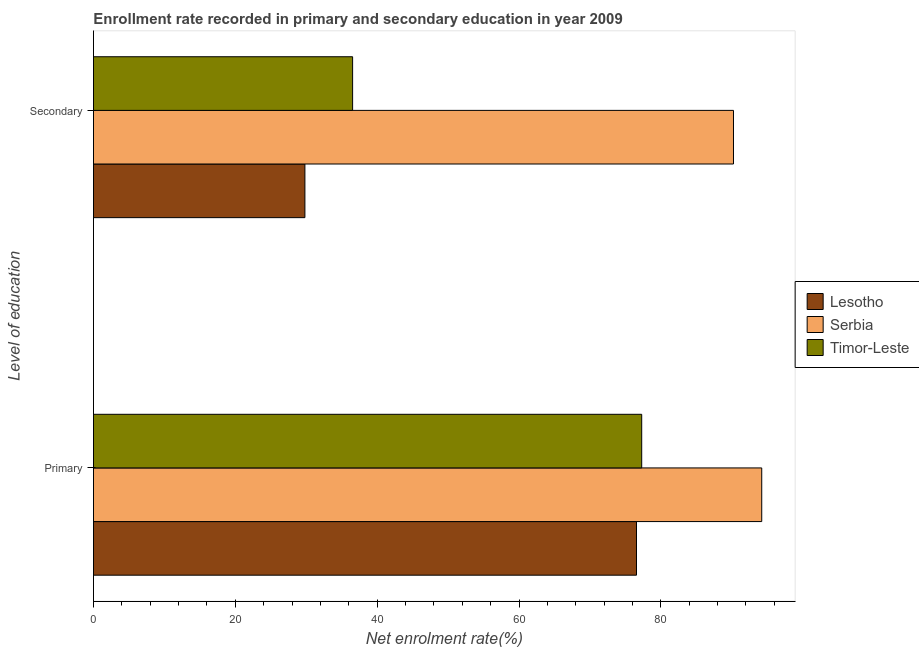How many different coloured bars are there?
Your response must be concise. 3. Are the number of bars per tick equal to the number of legend labels?
Ensure brevity in your answer.  Yes. Are the number of bars on each tick of the Y-axis equal?
Offer a very short reply. Yes. How many bars are there on the 2nd tick from the top?
Give a very brief answer. 3. How many bars are there on the 1st tick from the bottom?
Make the answer very short. 3. What is the label of the 1st group of bars from the top?
Keep it short and to the point. Secondary. What is the enrollment rate in primary education in Timor-Leste?
Your answer should be compact. 77.3. Across all countries, what is the maximum enrollment rate in secondary education?
Your response must be concise. 90.24. Across all countries, what is the minimum enrollment rate in secondary education?
Keep it short and to the point. 29.81. In which country was the enrollment rate in secondary education maximum?
Your answer should be compact. Serbia. In which country was the enrollment rate in primary education minimum?
Provide a short and direct response. Lesotho. What is the total enrollment rate in primary education in the graph?
Ensure brevity in your answer.  248.09. What is the difference between the enrollment rate in primary education in Lesotho and that in Serbia?
Offer a terse response. -17.66. What is the difference between the enrollment rate in primary education in Serbia and the enrollment rate in secondary education in Lesotho?
Keep it short and to the point. 64.41. What is the average enrollment rate in primary education per country?
Provide a short and direct response. 82.7. What is the difference between the enrollment rate in primary education and enrollment rate in secondary education in Lesotho?
Your response must be concise. 46.75. What is the ratio of the enrollment rate in secondary education in Serbia to that in Timor-Leste?
Provide a short and direct response. 2.47. In how many countries, is the enrollment rate in secondary education greater than the average enrollment rate in secondary education taken over all countries?
Your response must be concise. 1. What does the 2nd bar from the top in Primary represents?
Give a very brief answer. Serbia. What does the 2nd bar from the bottom in Secondary represents?
Keep it short and to the point. Serbia. How many bars are there?
Give a very brief answer. 6. Are all the bars in the graph horizontal?
Give a very brief answer. Yes. Does the graph contain any zero values?
Offer a very short reply. No. Does the graph contain grids?
Ensure brevity in your answer.  No. How many legend labels are there?
Provide a short and direct response. 3. How are the legend labels stacked?
Provide a short and direct response. Vertical. What is the title of the graph?
Give a very brief answer. Enrollment rate recorded in primary and secondary education in year 2009. What is the label or title of the X-axis?
Offer a terse response. Net enrolment rate(%). What is the label or title of the Y-axis?
Ensure brevity in your answer.  Level of education. What is the Net enrolment rate(%) in Lesotho in Primary?
Your response must be concise. 76.57. What is the Net enrolment rate(%) in Serbia in Primary?
Keep it short and to the point. 94.22. What is the Net enrolment rate(%) in Timor-Leste in Primary?
Provide a succinct answer. 77.3. What is the Net enrolment rate(%) of Lesotho in Secondary?
Provide a short and direct response. 29.81. What is the Net enrolment rate(%) in Serbia in Secondary?
Keep it short and to the point. 90.24. What is the Net enrolment rate(%) of Timor-Leste in Secondary?
Make the answer very short. 36.54. Across all Level of education, what is the maximum Net enrolment rate(%) in Lesotho?
Your answer should be very brief. 76.57. Across all Level of education, what is the maximum Net enrolment rate(%) in Serbia?
Offer a terse response. 94.22. Across all Level of education, what is the maximum Net enrolment rate(%) of Timor-Leste?
Offer a terse response. 77.3. Across all Level of education, what is the minimum Net enrolment rate(%) in Lesotho?
Your answer should be compact. 29.81. Across all Level of education, what is the minimum Net enrolment rate(%) in Serbia?
Your answer should be very brief. 90.24. Across all Level of education, what is the minimum Net enrolment rate(%) in Timor-Leste?
Ensure brevity in your answer.  36.54. What is the total Net enrolment rate(%) in Lesotho in the graph?
Provide a short and direct response. 106.38. What is the total Net enrolment rate(%) in Serbia in the graph?
Give a very brief answer. 184.46. What is the total Net enrolment rate(%) in Timor-Leste in the graph?
Make the answer very short. 113.84. What is the difference between the Net enrolment rate(%) of Lesotho in Primary and that in Secondary?
Make the answer very short. 46.75. What is the difference between the Net enrolment rate(%) of Serbia in Primary and that in Secondary?
Offer a terse response. 3.98. What is the difference between the Net enrolment rate(%) of Timor-Leste in Primary and that in Secondary?
Your answer should be very brief. 40.76. What is the difference between the Net enrolment rate(%) of Lesotho in Primary and the Net enrolment rate(%) of Serbia in Secondary?
Your response must be concise. -13.68. What is the difference between the Net enrolment rate(%) in Lesotho in Primary and the Net enrolment rate(%) in Timor-Leste in Secondary?
Make the answer very short. 40.03. What is the difference between the Net enrolment rate(%) in Serbia in Primary and the Net enrolment rate(%) in Timor-Leste in Secondary?
Make the answer very short. 57.69. What is the average Net enrolment rate(%) of Lesotho per Level of education?
Your response must be concise. 53.19. What is the average Net enrolment rate(%) in Serbia per Level of education?
Make the answer very short. 92.23. What is the average Net enrolment rate(%) of Timor-Leste per Level of education?
Provide a succinct answer. 56.92. What is the difference between the Net enrolment rate(%) of Lesotho and Net enrolment rate(%) of Serbia in Primary?
Your answer should be very brief. -17.66. What is the difference between the Net enrolment rate(%) in Lesotho and Net enrolment rate(%) in Timor-Leste in Primary?
Your answer should be very brief. -0.73. What is the difference between the Net enrolment rate(%) of Serbia and Net enrolment rate(%) of Timor-Leste in Primary?
Provide a succinct answer. 16.92. What is the difference between the Net enrolment rate(%) in Lesotho and Net enrolment rate(%) in Serbia in Secondary?
Ensure brevity in your answer.  -60.43. What is the difference between the Net enrolment rate(%) of Lesotho and Net enrolment rate(%) of Timor-Leste in Secondary?
Your answer should be very brief. -6.73. What is the difference between the Net enrolment rate(%) in Serbia and Net enrolment rate(%) in Timor-Leste in Secondary?
Provide a short and direct response. 53.7. What is the ratio of the Net enrolment rate(%) in Lesotho in Primary to that in Secondary?
Offer a very short reply. 2.57. What is the ratio of the Net enrolment rate(%) of Serbia in Primary to that in Secondary?
Ensure brevity in your answer.  1.04. What is the ratio of the Net enrolment rate(%) of Timor-Leste in Primary to that in Secondary?
Your response must be concise. 2.12. What is the difference between the highest and the second highest Net enrolment rate(%) of Lesotho?
Offer a terse response. 46.75. What is the difference between the highest and the second highest Net enrolment rate(%) of Serbia?
Keep it short and to the point. 3.98. What is the difference between the highest and the second highest Net enrolment rate(%) in Timor-Leste?
Provide a short and direct response. 40.76. What is the difference between the highest and the lowest Net enrolment rate(%) of Lesotho?
Your answer should be very brief. 46.75. What is the difference between the highest and the lowest Net enrolment rate(%) in Serbia?
Keep it short and to the point. 3.98. What is the difference between the highest and the lowest Net enrolment rate(%) of Timor-Leste?
Your answer should be very brief. 40.76. 